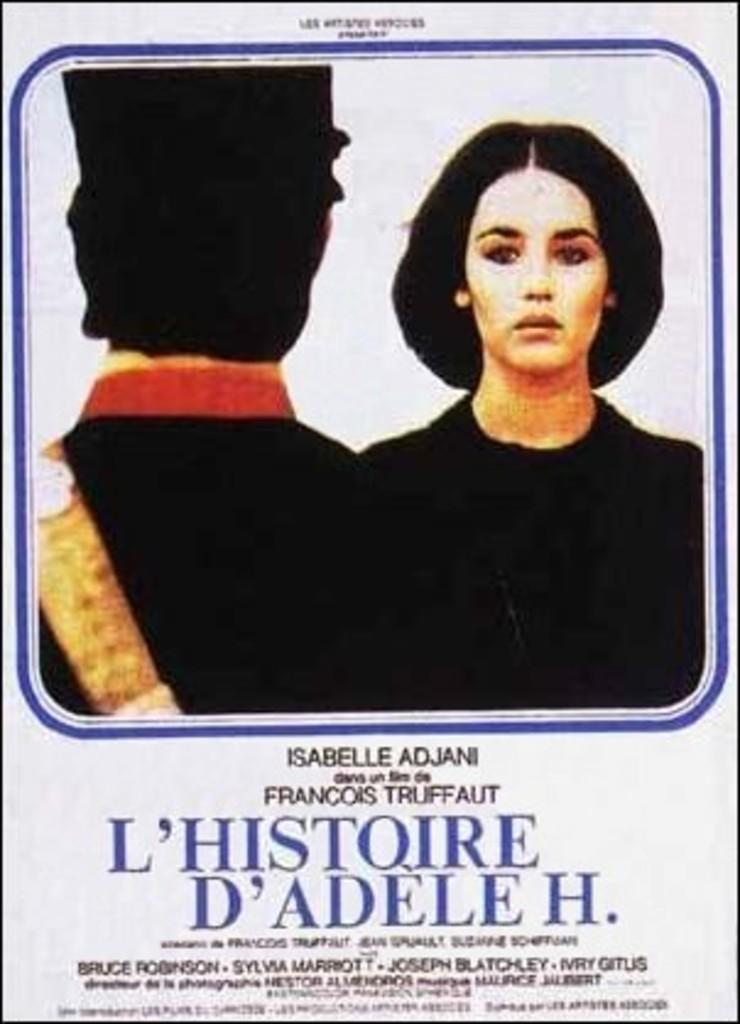What type of visual content might the image represent? The image might be a poster. What can be found at the top of the image? There is text at the top of the image. What can be found at the bottom of the image? There is text at the bottom of the image. How many people are in the image? There are two people in the center of the image. What type of humor can be found in the image? There is no indication of humor in the image, as it primarily features text and two people. Can you tell me how many quarters are visible in the image? There are no quarters present in the image. 